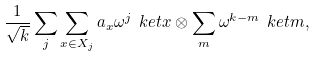<formula> <loc_0><loc_0><loc_500><loc_500>\frac { 1 } { \sqrt { k } } \sum _ { j } \sum _ { x \in X _ { j } } a _ { x } \omega ^ { j } \ k e t { x } \otimes \sum _ { m } \omega ^ { k - m } \ k e t { m } ,</formula> 